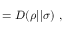<formula> <loc_0><loc_0><loc_500><loc_500>= D ( \rho | | \sigma ) ,</formula> 